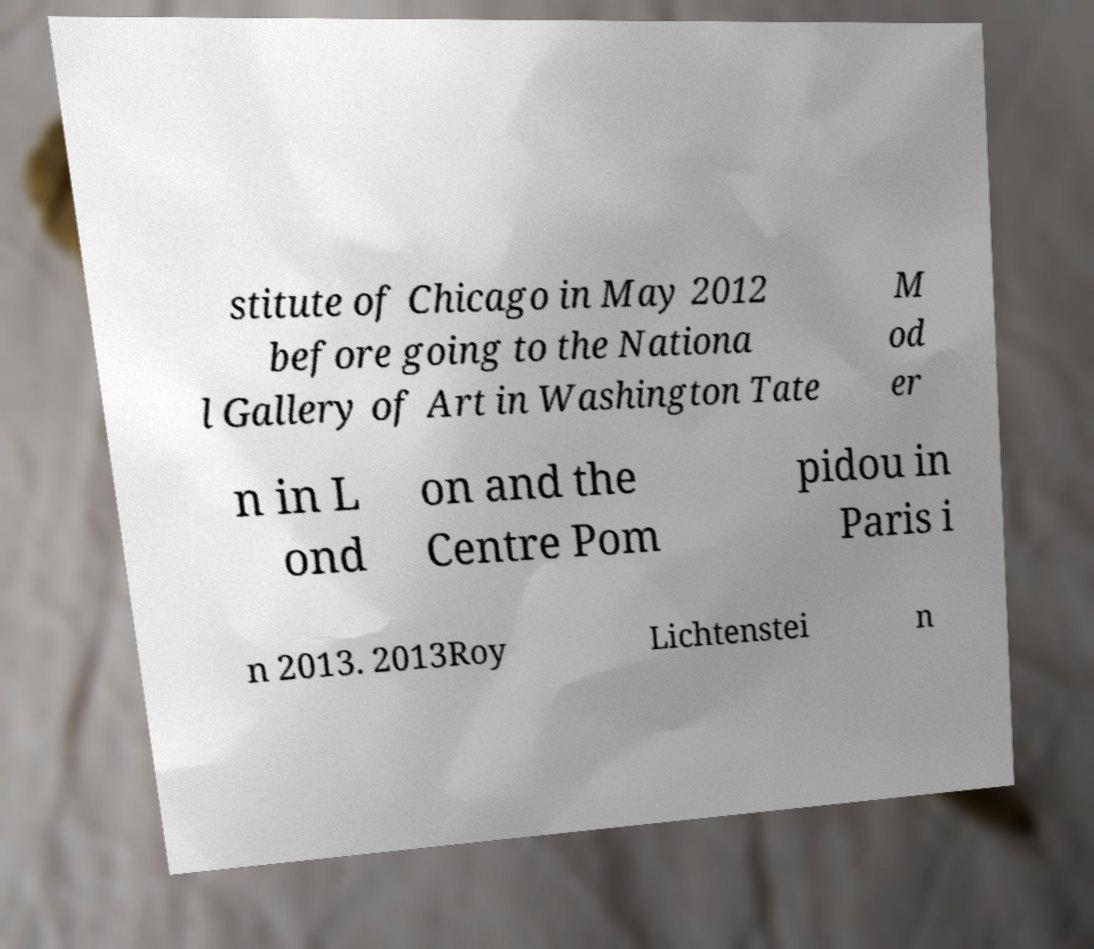Please identify and transcribe the text found in this image. stitute of Chicago in May 2012 before going to the Nationa l Gallery of Art in Washington Tate M od er n in L ond on and the Centre Pom pidou in Paris i n 2013. 2013Roy Lichtenstei n 